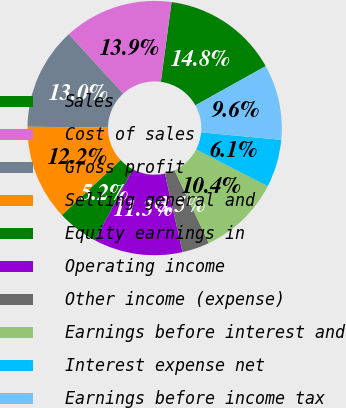<chart> <loc_0><loc_0><loc_500><loc_500><pie_chart><fcel>Sales<fcel>Cost of sales<fcel>Gross profit<fcel>Selling general and<fcel>Equity earnings in<fcel>Operating income<fcel>Other income (expense)<fcel>Earnings before interest and<fcel>Interest expense net<fcel>Earnings before income tax<nl><fcel>14.78%<fcel>13.91%<fcel>13.04%<fcel>12.17%<fcel>5.22%<fcel>11.3%<fcel>3.48%<fcel>10.43%<fcel>6.09%<fcel>9.57%<nl></chart> 